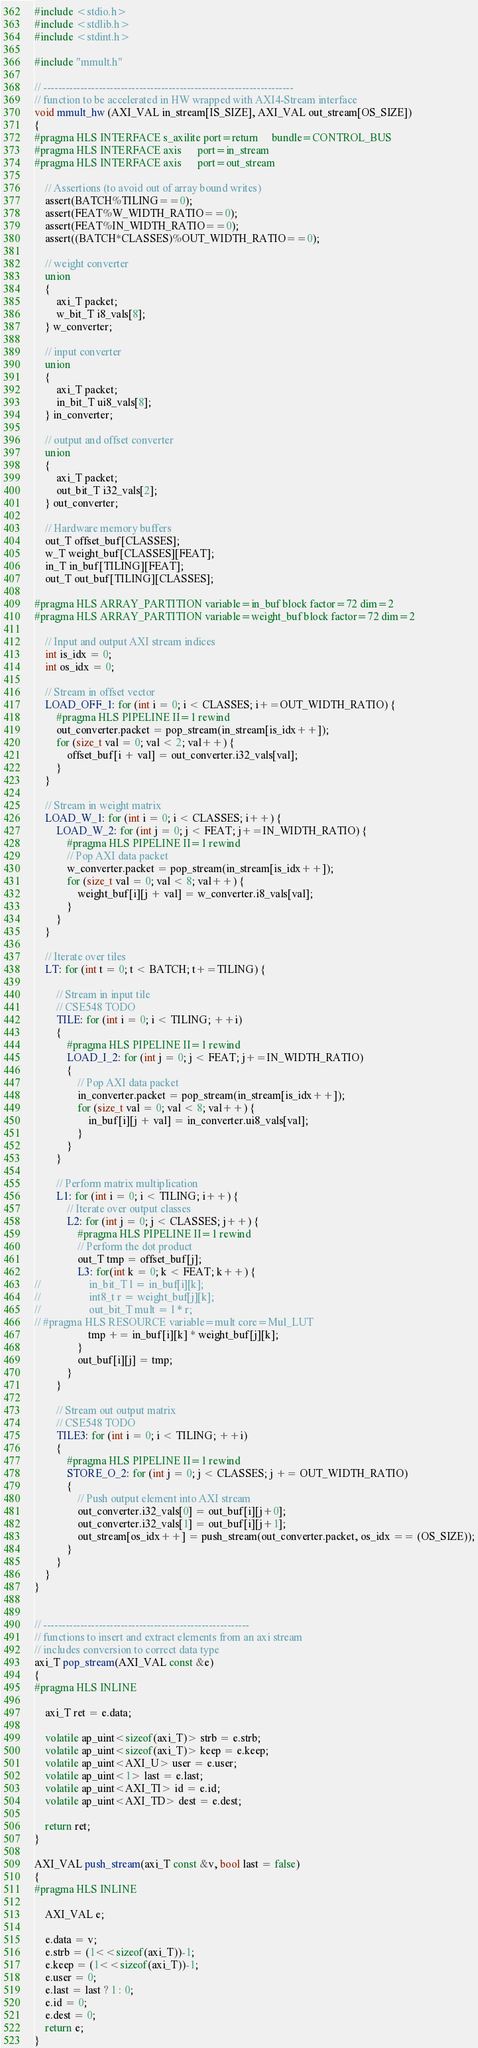<code> <loc_0><loc_0><loc_500><loc_500><_C++_>#include <stdio.h>
#include <stdlib.h>
#include <stdint.h>

#include "mmult.h"

// --------------------------------------------------------------------
// function to be accelerated in HW wrapped with AXI4-Stream interface
void mmult_hw (AXI_VAL in_stream[IS_SIZE], AXI_VAL out_stream[OS_SIZE])
{
#pragma HLS INTERFACE s_axilite port=return     bundle=CONTROL_BUS
#pragma HLS INTERFACE axis      port=in_stream
#pragma HLS INTERFACE axis      port=out_stream

	// Assertions (to avoid out of array bound writes)
	assert(BATCH%TILING==0);
	assert(FEAT%W_WIDTH_RATIO==0);
	assert(FEAT%IN_WIDTH_RATIO==0);
	assert((BATCH*CLASSES)%OUT_WIDTH_RATIO==0);

	// weight converter
	union
	{
		axi_T packet;
		w_bit_T i8_vals[8];
	} w_converter;

	// input converter
	union
	{
		axi_T packet;
		in_bit_T ui8_vals[8];
	} in_converter;

	// output and offset converter
	union
	{
		axi_T packet;
		out_bit_T i32_vals[2];
	} out_converter;

	// Hardware memory buffers
	out_T offset_buf[CLASSES];
	w_T weight_buf[CLASSES][FEAT];
	in_T in_buf[TILING][FEAT];
	out_T out_buf[TILING][CLASSES];

#pragma HLS ARRAY_PARTITION variable=in_buf block factor=72 dim=2
#pragma HLS ARRAY_PARTITION variable=weight_buf block factor=72 dim=2

	// Input and output AXI stream indices
	int is_idx = 0;
	int os_idx = 0;

	// Stream in offset vector
	LOAD_OFF_1: for (int i = 0; i < CLASSES; i+=OUT_WIDTH_RATIO) {
		#pragma HLS PIPELINE II=1 rewind
		out_converter.packet = pop_stream(in_stream[is_idx++]);
		for (size_t val = 0; val < 2; val++) {
			offset_buf[i + val] = out_converter.i32_vals[val];
		}
	}

	// Stream in weight matrix
	LOAD_W_1: for (int i = 0; i < CLASSES; i++) {
		LOAD_W_2: for (int j = 0; j < FEAT; j+=IN_WIDTH_RATIO) {
			#pragma HLS PIPELINE II=1 rewind
			// Pop AXI data packet
			w_converter.packet = pop_stream(in_stream[is_idx++]);
			for (size_t val = 0; val < 8; val++) {
				weight_buf[i][j + val] = w_converter.i8_vals[val];
			}
		}
	}

	// Iterate over tiles
	LT: for (int t = 0; t < BATCH; t+=TILING) {

		// Stream in input tile
		// CSE548 TODO
		TILE: for (int i = 0; i < TILING; ++i)
		{
			#pragma HLS PIPELINE II=1 rewind
			LOAD_I_2: for (int j = 0; j < FEAT; j+=IN_WIDTH_RATIO)
			{
				// Pop AXI data packet
				in_converter.packet = pop_stream(in_stream[is_idx++]);
				for (size_t val = 0; val < 8; val++) {
					in_buf[i][j + val] = in_converter.ui8_vals[val];
				}
			}
		}

		// Perform matrix multiplication
		L1: for (int i = 0; i < TILING; i++) {
			// Iterate over output classes
			L2: for (int j = 0; j < CLASSES; j++) {
				#pragma HLS PIPELINE II=1 rewind
				// Perform the dot product
				out_T tmp = offset_buf[j];
				L3: for(int k = 0; k < FEAT; k++) {
// 					in_bit_T l = in_buf[i][k];
// 					int8_t r = weight_buf[j][k];
// 					out_bit_T mult = l * r;
// #pragma HLS RESOURCE variable=mult core=Mul_LUT
					tmp += in_buf[i][k] * weight_buf[j][k];
				}
				out_buf[i][j] = tmp;
			}
		}

		// Stream out output matrix
		// CSE548 TODO
		TILE3: for (int i = 0; i < TILING; ++i)
		{
			#pragma HLS PIPELINE II=1 rewind
			STORE_O_2: for (int j = 0; j < CLASSES; j += OUT_WIDTH_RATIO)
			{
				// Push output element into AXI stream
				out_converter.i32_vals[0] = out_buf[i][j+0];
				out_converter.i32_vals[1] = out_buf[i][j+1];
				out_stream[os_idx++] = push_stream(out_converter.packet, os_idx == (OS_SIZE));
			}
		}
	}
}


// --------------------------------------------------------
// functions to insert and extract elements from an axi stream
// includes conversion to correct data type
axi_T pop_stream(AXI_VAL const &e)
{
#pragma HLS INLINE

	axi_T ret = e.data;

	volatile ap_uint<sizeof(axi_T)> strb = e.strb;
	volatile ap_uint<sizeof(axi_T)> keep = e.keep;
	volatile ap_uint<AXI_U> user = e.user;
	volatile ap_uint<1> last = e.last;
	volatile ap_uint<AXI_TI> id = e.id;
	volatile ap_uint<AXI_TD> dest = e.dest;

	return ret;
}

AXI_VAL push_stream(axi_T const &v, bool last = false)
{
#pragma HLS INLINE

	AXI_VAL e;

	e.data = v;
	e.strb = (1<<sizeof(axi_T))-1;
	e.keep = (1<<sizeof(axi_T))-1;
	e.user = 0;
	e.last = last ? 1 : 0;
	e.id = 0;
	e.dest = 0;
	return e;
}
</code> 